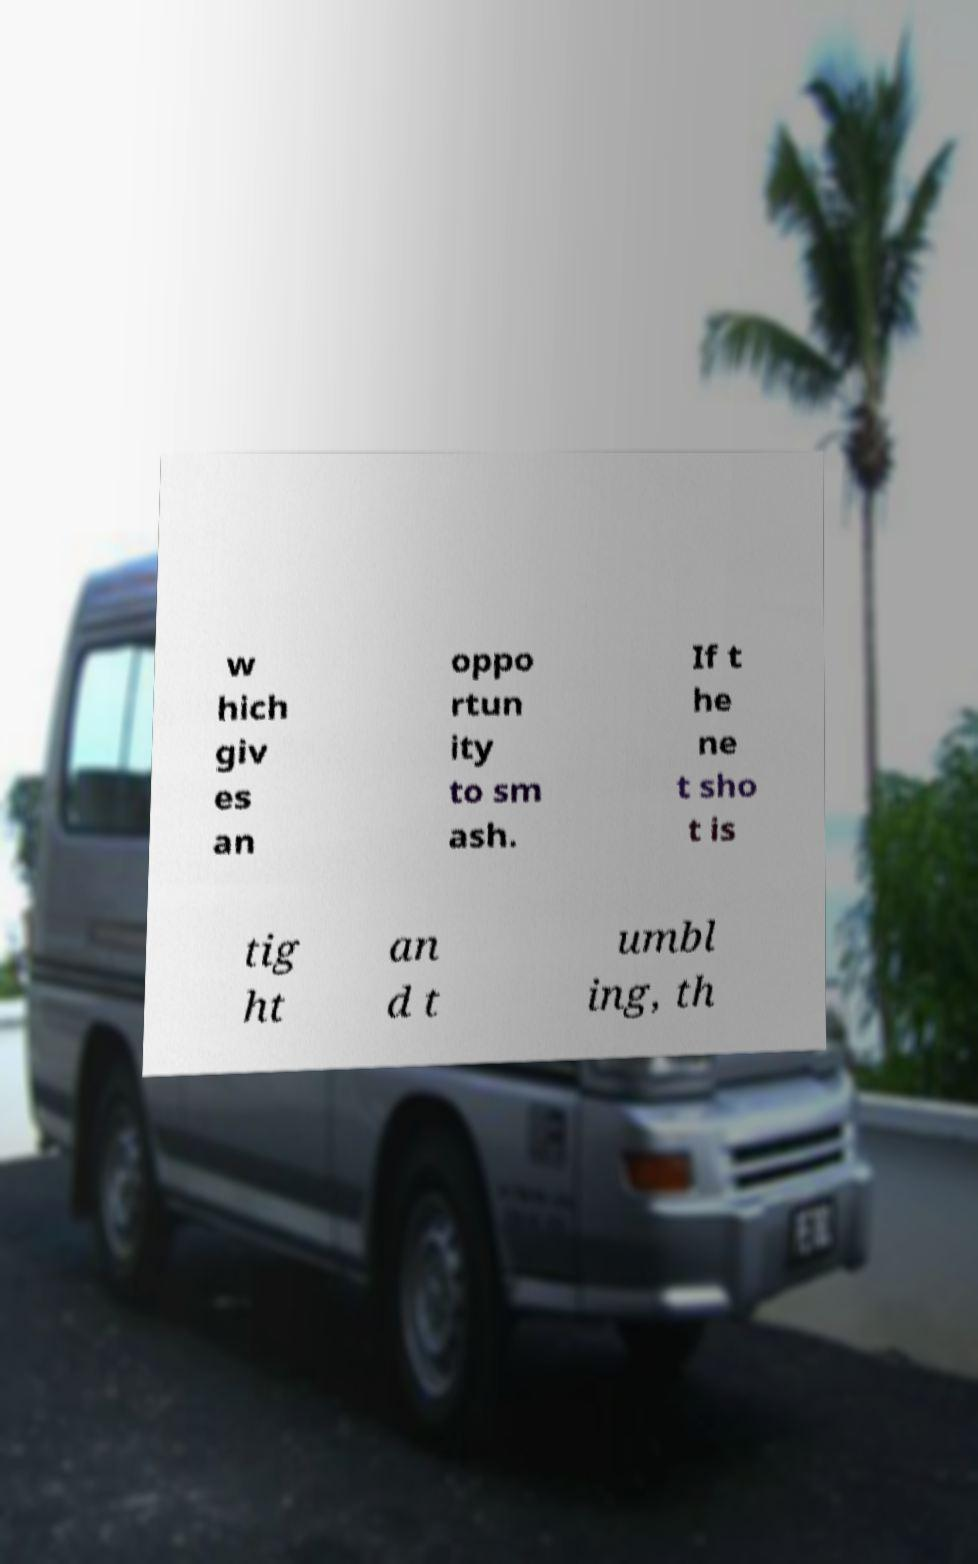Could you assist in decoding the text presented in this image and type it out clearly? w hich giv es an oppo rtun ity to sm ash. If t he ne t sho t is tig ht an d t umbl ing, th 